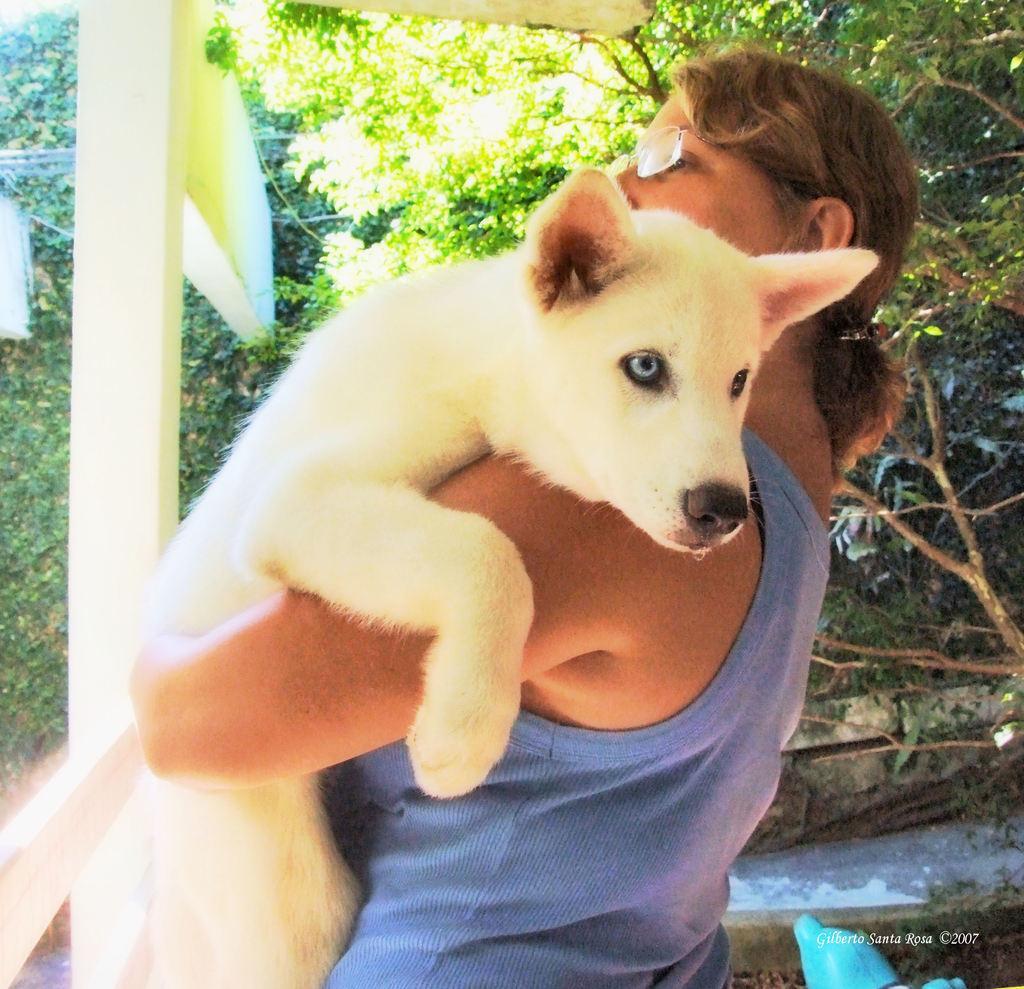In one or two sentences, can you explain what this image depicts? In this image I can see a woman is standing, I can see she is holding a white colour dog and in the background I can see number of trees. 